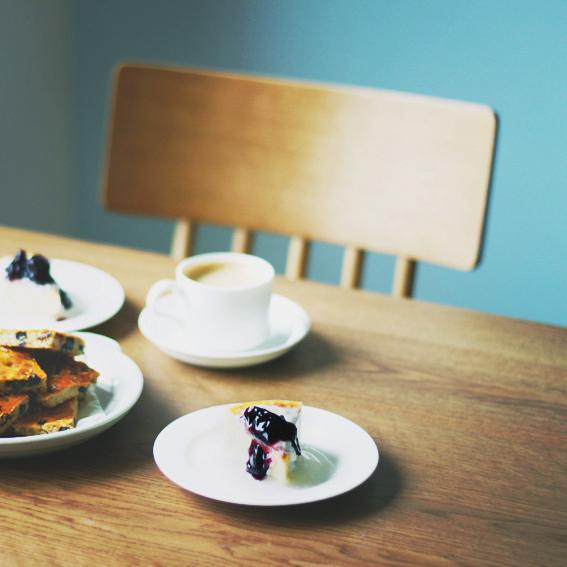How many cakes can you see?
Give a very brief answer. 2. How many umbrellas with yellow stripes are on the beach?
Give a very brief answer. 0. 